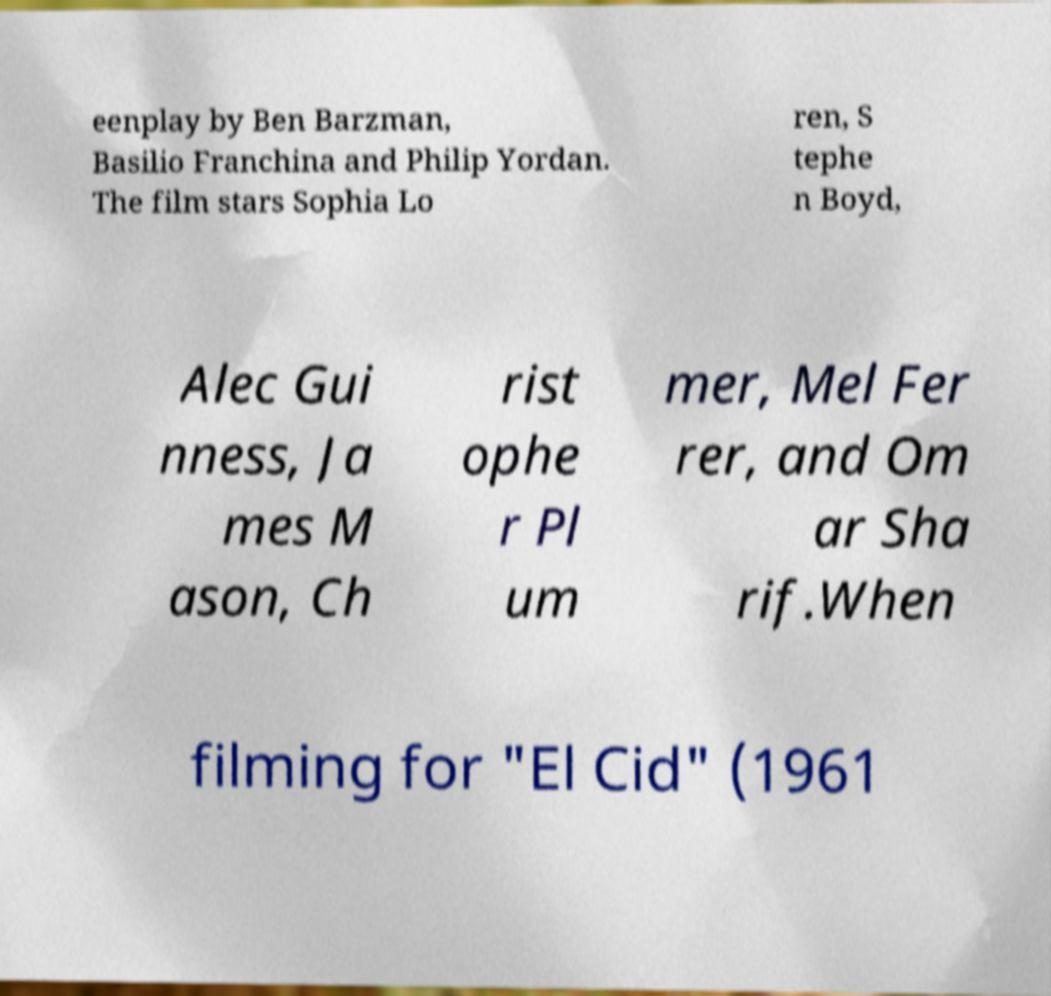Can you read and provide the text displayed in the image?This photo seems to have some interesting text. Can you extract and type it out for me? eenplay by Ben Barzman, Basilio Franchina and Philip Yordan. The film stars Sophia Lo ren, S tephe n Boyd, Alec Gui nness, Ja mes M ason, Ch rist ophe r Pl um mer, Mel Fer rer, and Om ar Sha rif.When filming for "El Cid" (1961 